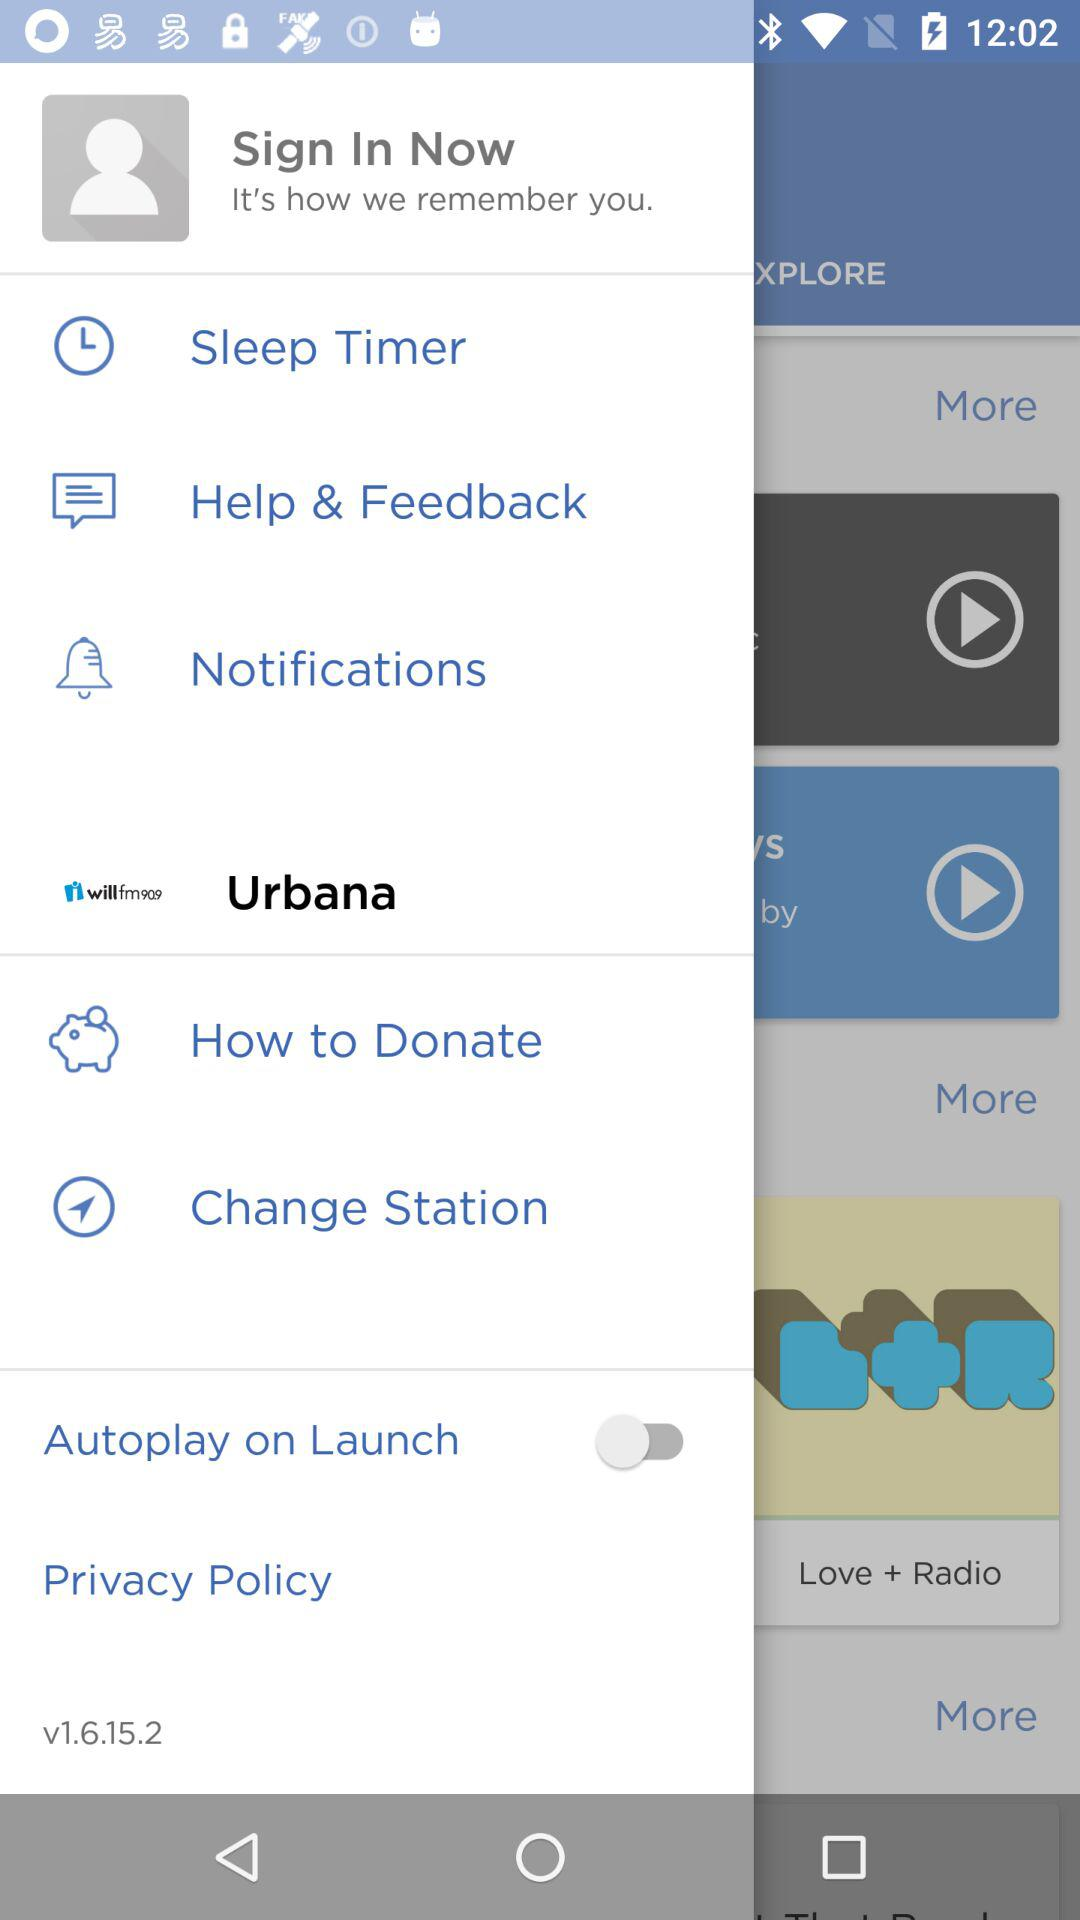What is the version? The version is v1.6.15.2. 